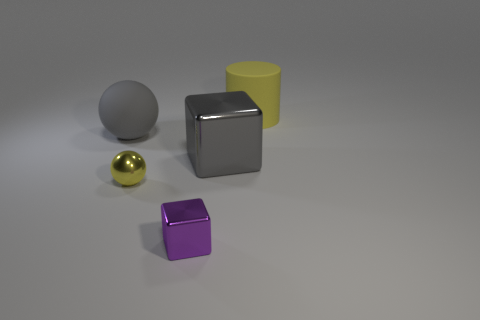Add 3 big gray matte cylinders. How many objects exist? 8 Subtract all cylinders. How many objects are left? 4 Add 2 small purple objects. How many small purple objects exist? 3 Subtract 0 cyan cylinders. How many objects are left? 5 Subtract all big shiny spheres. Subtract all shiny cubes. How many objects are left? 3 Add 4 tiny purple objects. How many tiny purple objects are left? 5 